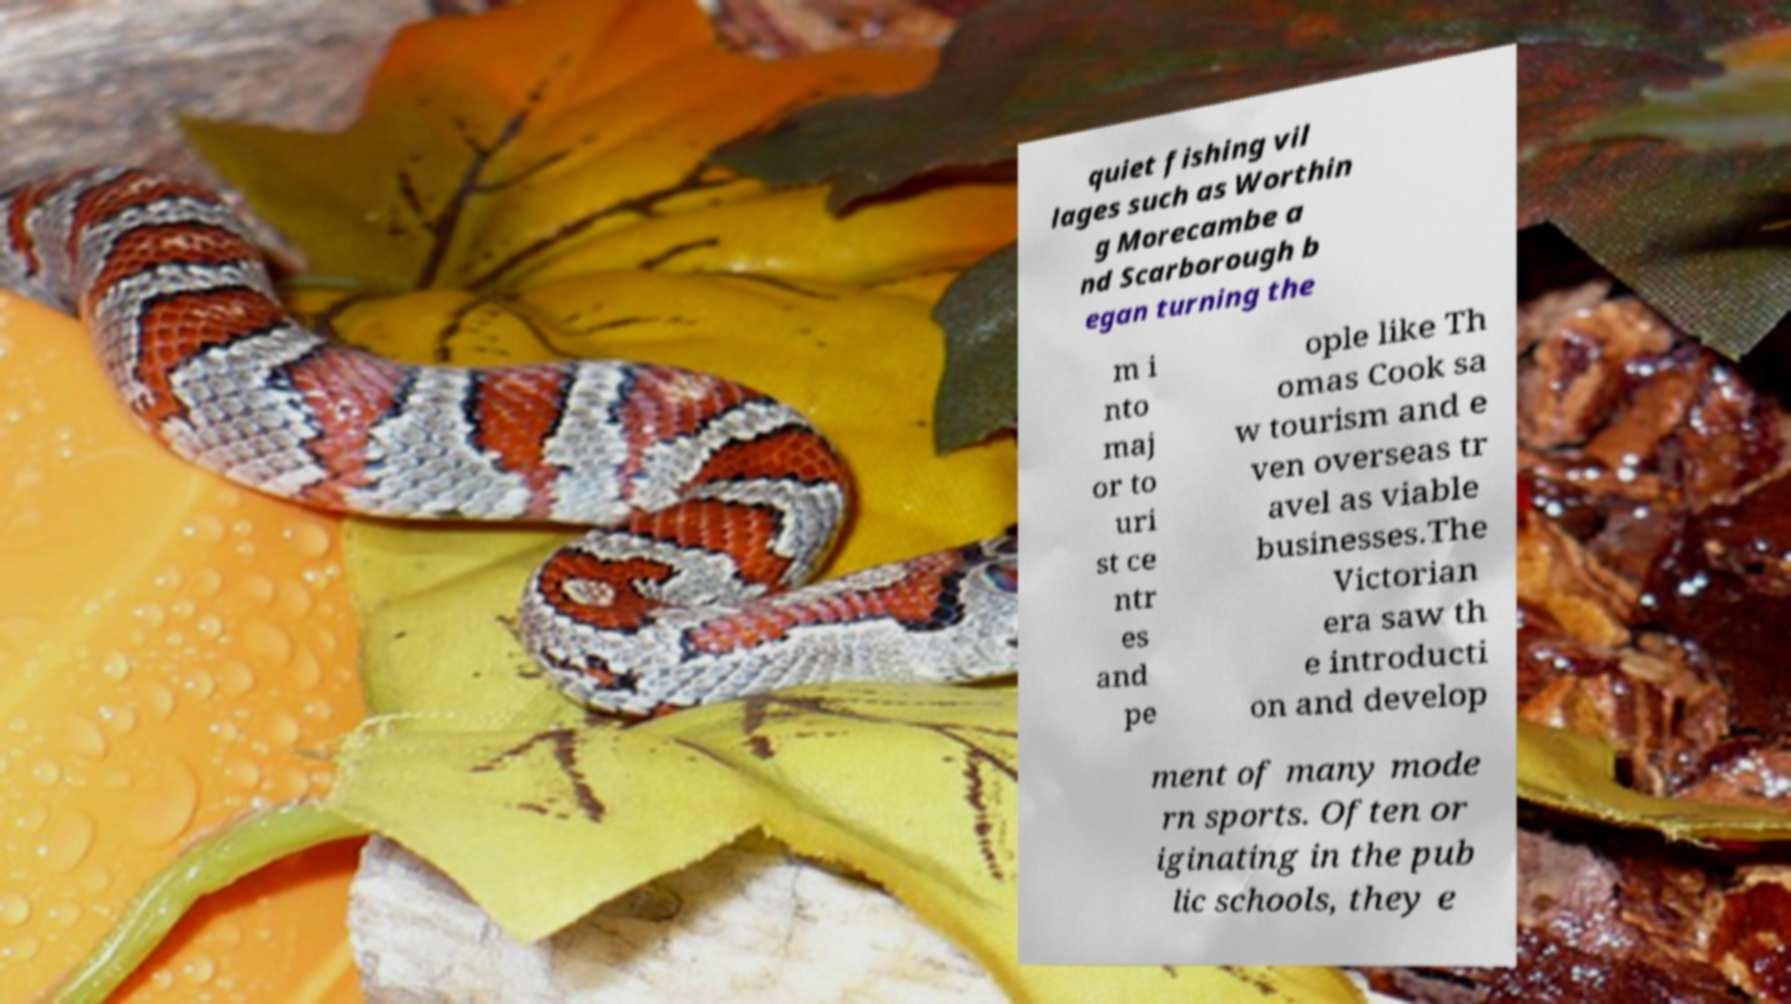Could you extract and type out the text from this image? quiet fishing vil lages such as Worthin g Morecambe a nd Scarborough b egan turning the m i nto maj or to uri st ce ntr es and pe ople like Th omas Cook sa w tourism and e ven overseas tr avel as viable businesses.The Victorian era saw th e introducti on and develop ment of many mode rn sports. Often or iginating in the pub lic schools, they e 